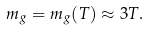Convert formula to latex. <formula><loc_0><loc_0><loc_500><loc_500>m _ { g } = m _ { g } ( T ) \approx 3 T .</formula> 